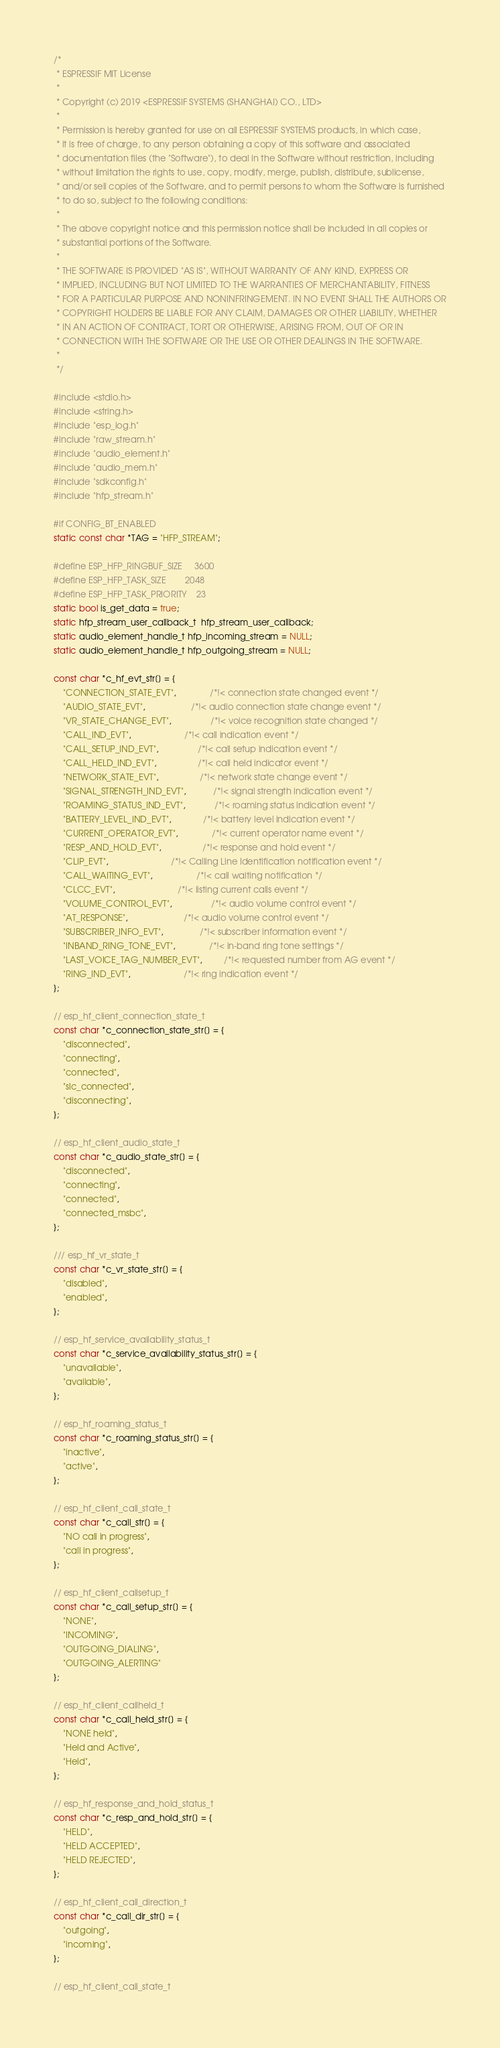Convert code to text. <code><loc_0><loc_0><loc_500><loc_500><_C_>/*
 * ESPRESSIF MIT License
 *
 * Copyright (c) 2019 <ESPRESSIF SYSTEMS (SHANGHAI) CO., LTD>
 *
 * Permission is hereby granted for use on all ESPRESSIF SYSTEMS products, in which case,
 * it is free of charge, to any person obtaining a copy of this software and associated
 * documentation files (the "Software"), to deal in the Software without restriction, including
 * without limitation the rights to use, copy, modify, merge, publish, distribute, sublicense,
 * and/or sell copies of the Software, and to permit persons to whom the Software is furnished
 * to do so, subject to the following conditions:
 *
 * The above copyright notice and this permission notice shall be included in all copies or
 * substantial portions of the Software.
 *
 * THE SOFTWARE IS PROVIDED "AS IS", WITHOUT WARRANTY OF ANY KIND, EXPRESS OR
 * IMPLIED, INCLUDING BUT NOT LIMITED TO THE WARRANTIES OF MERCHANTABILITY, FITNESS
 * FOR A PARTICULAR PURPOSE AND NONINFRINGEMENT. IN NO EVENT SHALL THE AUTHORS OR
 * COPYRIGHT HOLDERS BE LIABLE FOR ANY CLAIM, DAMAGES OR OTHER LIABILITY, WHETHER
 * IN AN ACTION OF CONTRACT, TORT OR OTHERWISE, ARISING FROM, OUT OF OR IN
 * CONNECTION WITH THE SOFTWARE OR THE USE OR OTHER DEALINGS IN THE SOFTWARE.
 *
 */

#include <stdio.h>
#include <string.h>
#include "esp_log.h"
#include "raw_stream.h"
#include "audio_element.h"
#include "audio_mem.h"
#include "sdkconfig.h"
#include "hfp_stream.h"

#if CONFIG_BT_ENABLED
static const char *TAG = "HFP_STREAM";

#define ESP_HFP_RINGBUF_SIZE     3600
#define ESP_HFP_TASK_SIZE        2048
#define ESP_HFP_TASK_PRIORITY    23
static bool is_get_data = true;
static hfp_stream_user_callback_t  hfp_stream_user_callback;
static audio_element_handle_t hfp_incoming_stream = NULL;
static audio_element_handle_t hfp_outgoing_stream = NULL;

const char *c_hf_evt_str[] = {
    "CONNECTION_STATE_EVT",              /*!< connection state changed event */
    "AUDIO_STATE_EVT",                   /*!< audio connection state change event */
    "VR_STATE_CHANGE_EVT",                /*!< voice recognition state changed */
    "CALL_IND_EVT",                      /*!< call indication event */
    "CALL_SETUP_IND_EVT",                /*!< call setup indication event */
    "CALL_HELD_IND_EVT",                 /*!< call held indicator event */
    "NETWORK_STATE_EVT",                 /*!< network state change event */
    "SIGNAL_STRENGTH_IND_EVT",           /*!< signal strength indication event */
    "ROAMING_STATUS_IND_EVT",            /*!< roaming status indication event */
    "BATTERY_LEVEL_IND_EVT",             /*!< battery level indication event */
    "CURRENT_OPERATOR_EVT",              /*!< current operator name event */
    "RESP_AND_HOLD_EVT",                 /*!< response and hold event */
    "CLIP_EVT",                          /*!< Calling Line Identification notification event */
    "CALL_WAITING_EVT",                  /*!< call waiting notification */
    "CLCC_EVT",                          /*!< listing current calls event */
    "VOLUME_CONTROL_EVT",                /*!< audio volume control event */
    "AT_RESPONSE",                       /*!< audio volume control event */
    "SUBSCRIBER_INFO_EVT",               /*!< subscriber information event */
    "INBAND_RING_TONE_EVT",              /*!< in-band ring tone settings */
    "LAST_VOICE_TAG_NUMBER_EVT",         /*!< requested number from AG event */
    "RING_IND_EVT",                      /*!< ring indication event */
};

// esp_hf_client_connection_state_t
const char *c_connection_state_str[] = {
    "disconnected",
    "connecting",
    "connected",
    "slc_connected",
    "disconnecting",
};

// esp_hf_client_audio_state_t
const char *c_audio_state_str[] = {
    "disconnected",
    "connecting",
    "connected",
    "connected_msbc",
};

/// esp_hf_vr_state_t
const char *c_vr_state_str[] = {
    "disabled",
    "enabled",
};

// esp_hf_service_availability_status_t
const char *c_service_availability_status_str[] = {
    "unavailable",
    "available",
};

// esp_hf_roaming_status_t
const char *c_roaming_status_str[] = {
    "inactive",
    "active",
};

// esp_hf_client_call_state_t
const char *c_call_str[] = {
    "NO call in progress",
    "call in progress",
};

// esp_hf_client_callsetup_t
const char *c_call_setup_str[] = {
    "NONE",
    "INCOMING",
    "OUTGOING_DIALING",
    "OUTGOING_ALERTING"
};

// esp_hf_client_callheld_t
const char *c_call_held_str[] = {
    "NONE held",
    "Held and Active",
    "Held",
};

// esp_hf_response_and_hold_status_t
const char *c_resp_and_hold_str[] = {
    "HELD",
    "HELD ACCEPTED",
    "HELD REJECTED",
};

// esp_hf_client_call_direction_t
const char *c_call_dir_str[] = {
    "outgoing",
    "incoming",
};

// esp_hf_client_call_state_t</code> 